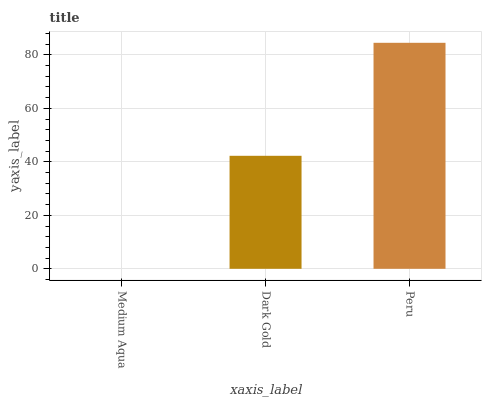Is Medium Aqua the minimum?
Answer yes or no. Yes. Is Peru the maximum?
Answer yes or no. Yes. Is Dark Gold the minimum?
Answer yes or no. No. Is Dark Gold the maximum?
Answer yes or no. No. Is Dark Gold greater than Medium Aqua?
Answer yes or no. Yes. Is Medium Aqua less than Dark Gold?
Answer yes or no. Yes. Is Medium Aqua greater than Dark Gold?
Answer yes or no. No. Is Dark Gold less than Medium Aqua?
Answer yes or no. No. Is Dark Gold the high median?
Answer yes or no. Yes. Is Dark Gold the low median?
Answer yes or no. Yes. Is Peru the high median?
Answer yes or no. No. Is Medium Aqua the low median?
Answer yes or no. No. 